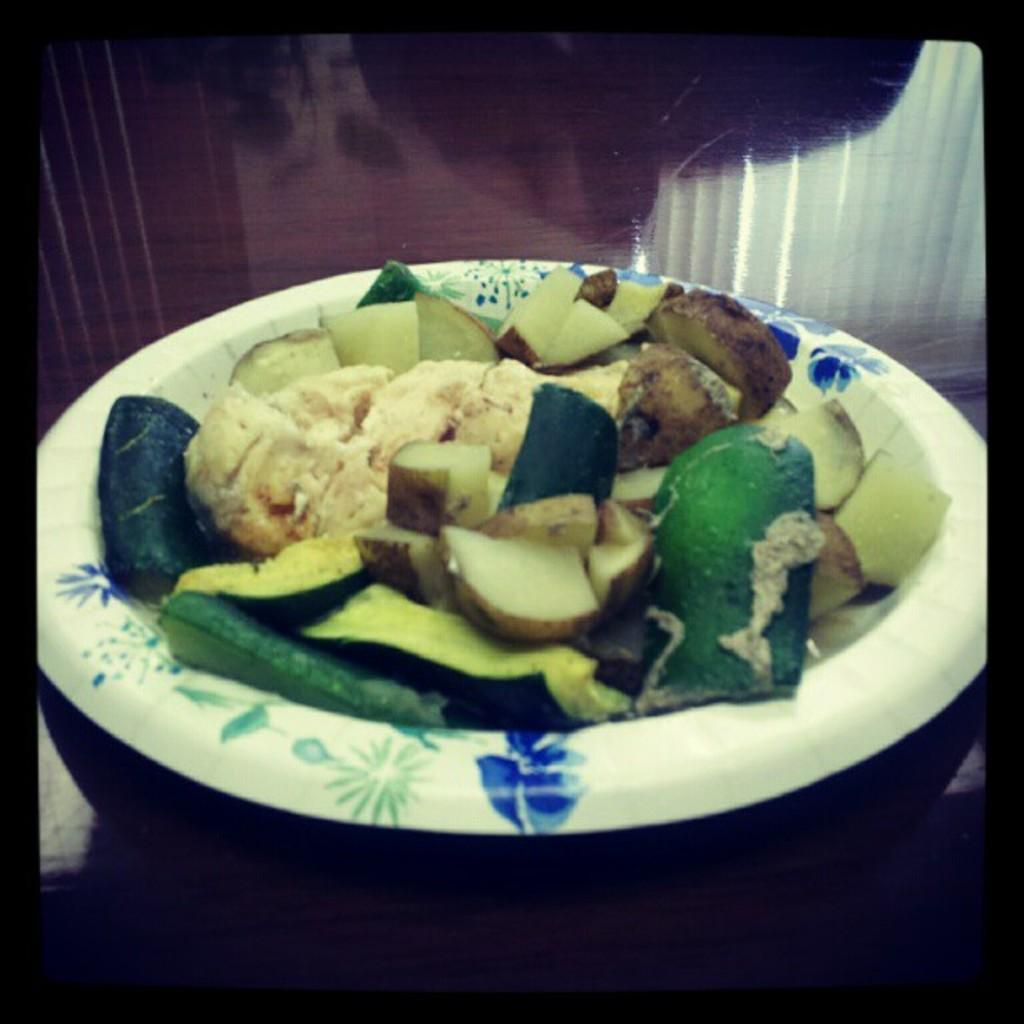What is present in the image related to food? There is food in the image. How is the food arranged or contained? The food is in a plate. Where is the plate with food located? The plate is on a table. How many rings are visible on the plate in the image? There are no rings visible on the plate in the image. What type of pocket is present in the image? There is no pocket present in the image. 